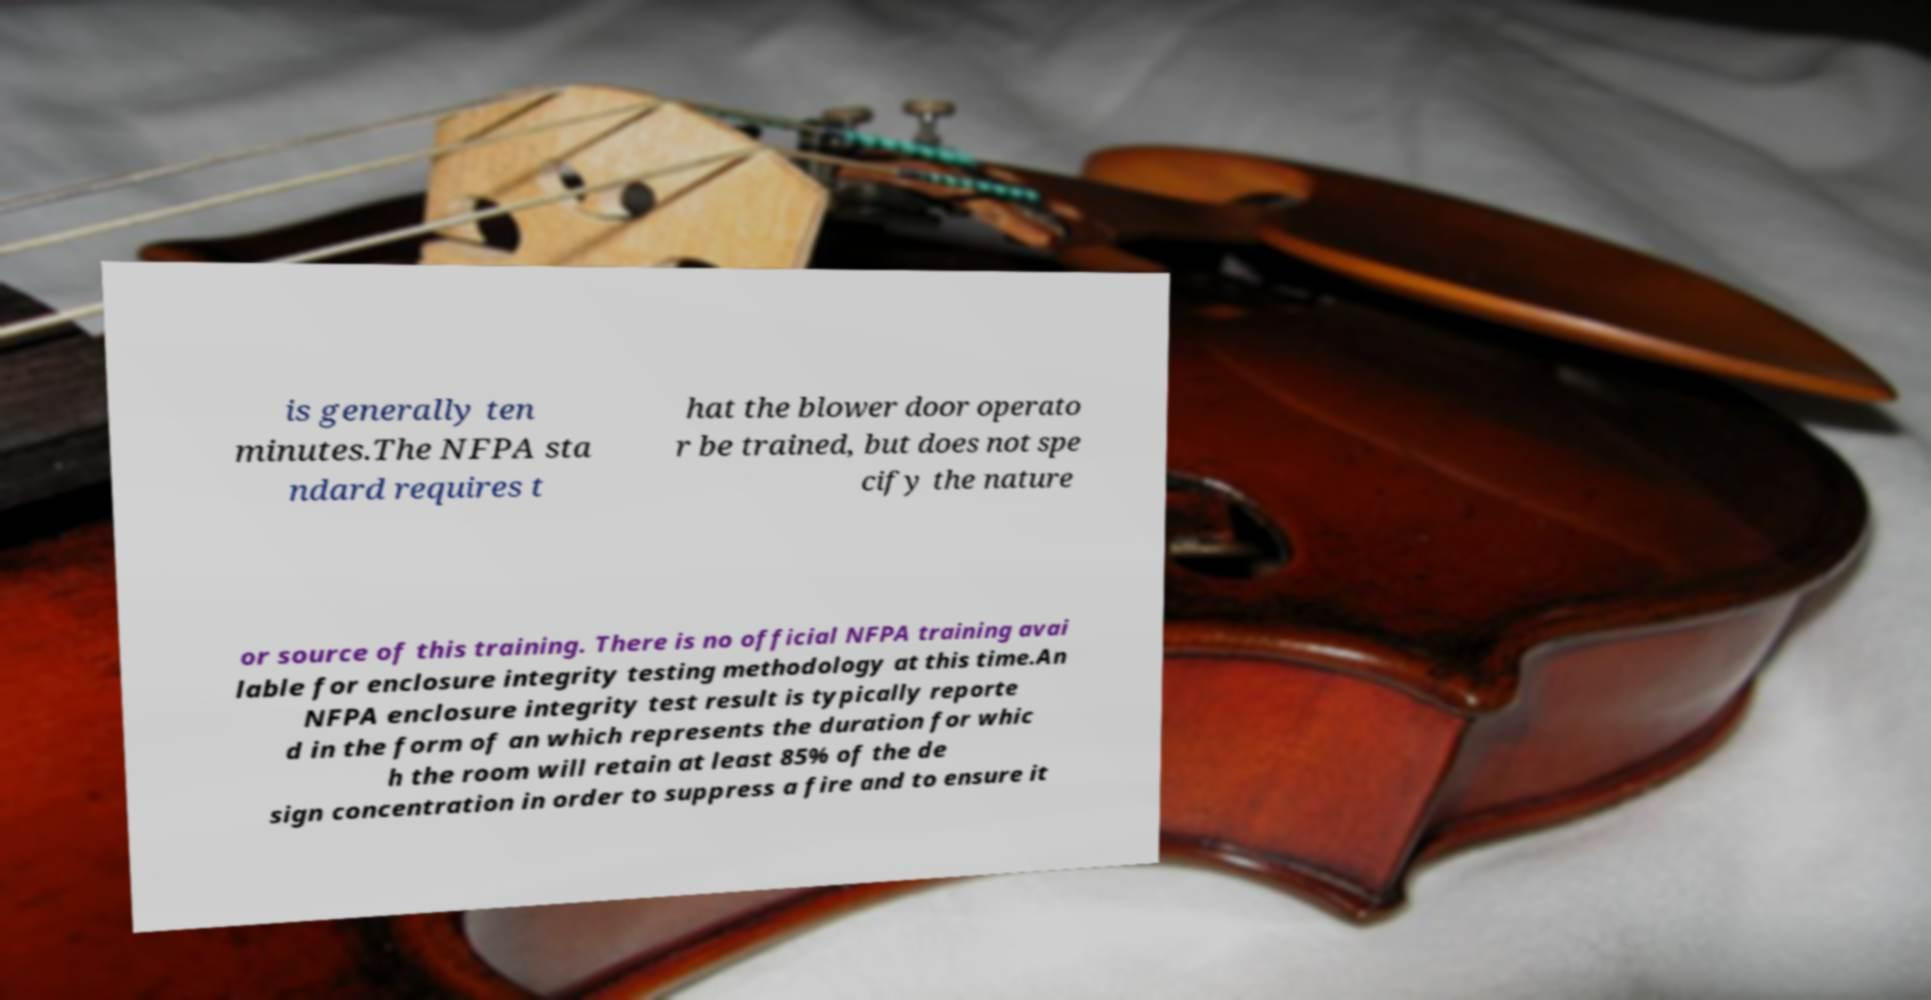Can you read and provide the text displayed in the image?This photo seems to have some interesting text. Can you extract and type it out for me? is generally ten minutes.The NFPA sta ndard requires t hat the blower door operato r be trained, but does not spe cify the nature or source of this training. There is no official NFPA training avai lable for enclosure integrity testing methodology at this time.An NFPA enclosure integrity test result is typically reporte d in the form of an which represents the duration for whic h the room will retain at least 85% of the de sign concentration in order to suppress a fire and to ensure it 